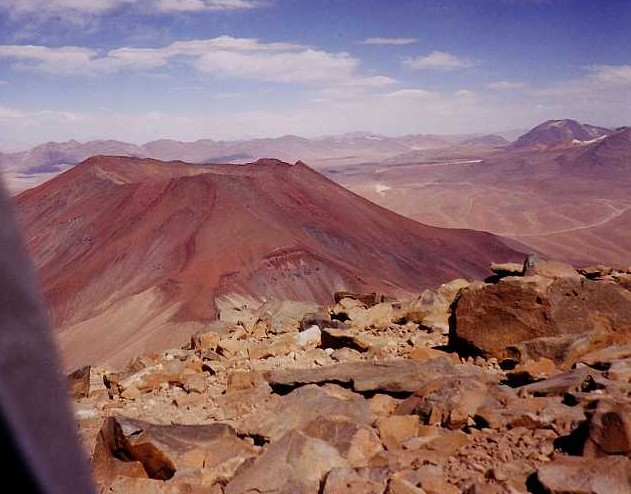What implications might the geological characteristics of this mountain have for local wildlife? The unique geological features of the mountain, including its mineral-rich soils and potential volcanic activity, create diverse habitats. Iron-rich soils, for instance, can support certain types of vegetation that are particularly adaptive to metal-rich conditions, attracting specific wildlife adapted to these environments. Additionally, if volcanic activity is recent, the region may experience regeneration, where new ecosystems begin to thrive following an eruption. 